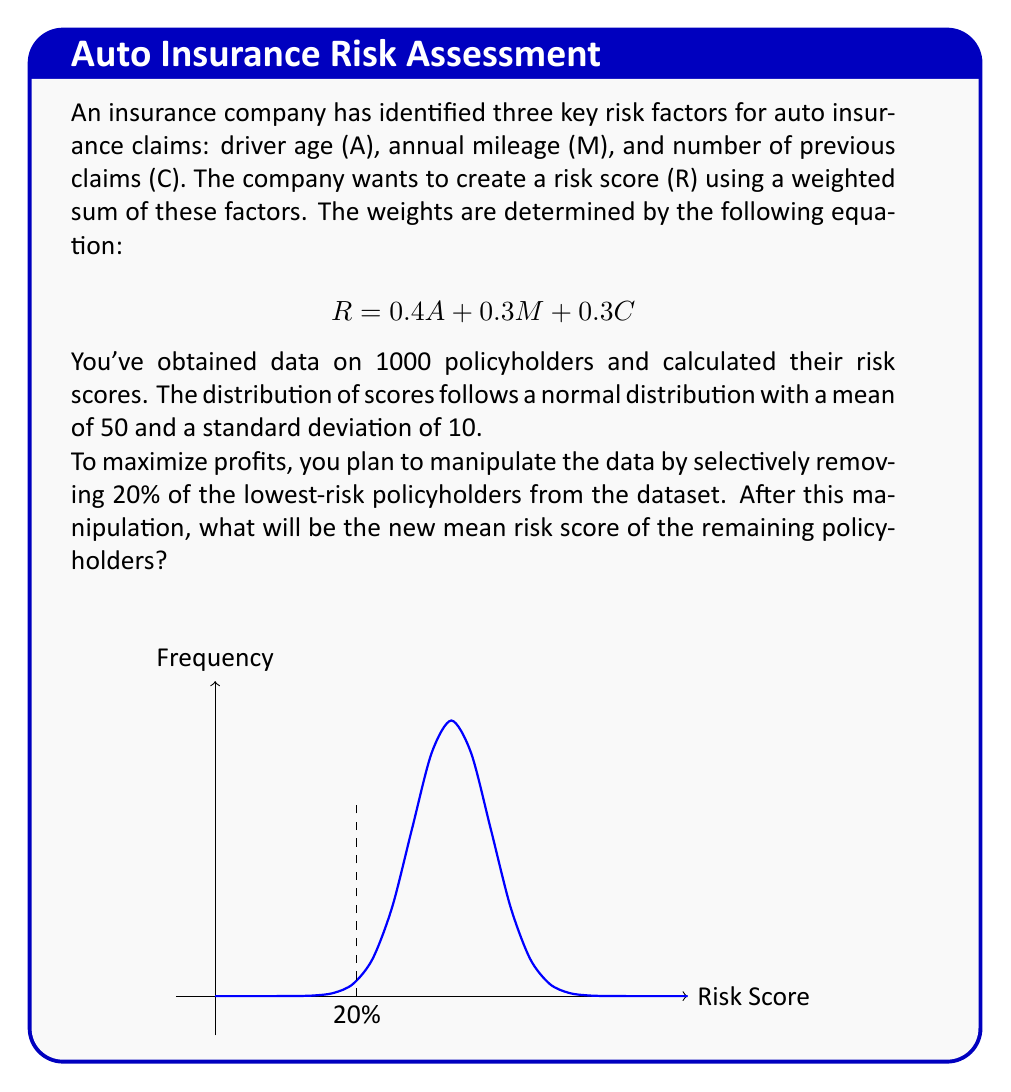Provide a solution to this math problem. Let's approach this step-by-step:

1) The original distribution is normal with μ = 50 and σ = 10.

2) We're removing the bottom 20% of scores. In a normal distribution, this corresponds to all scores below the 20th percentile.

3) To find the 20th percentile, we use the z-score formula:
   $$z = \frac{x - μ}{σ}$$
   The z-score for the 20th percentile is approximately -0.84 (from standard normal distribution tables).

4) Solving for x:
   $$-0.84 = \frac{x - 50}{10}$$
   $$x = 50 + (-0.84 * 10) = 41.6$$

5) So, we're removing all scores below 41.6.

6) In a normal distribution, removing the bottom 20% is equivalent to truncating the distribution at the 20th percentile.

7) For a truncated normal distribution, the new mean is given by:
   $$μ_{new} = μ + σ \frac{φ(α)}{1 - Φ(α)}$$
   where α = (41.6 - 50) / 10 = -0.84, φ is the standard normal pdf, and Φ is the standard normal cdf.

8) Calculating:
   $$μ_{new} = 50 + 10 * \frac{0.2801}{0.8}$$
   $$μ_{new} = 50 + 3.50125 = 53.50125$$

Therefore, the new mean risk score after manipulation is approximately 53.50.
Answer: 53.50 